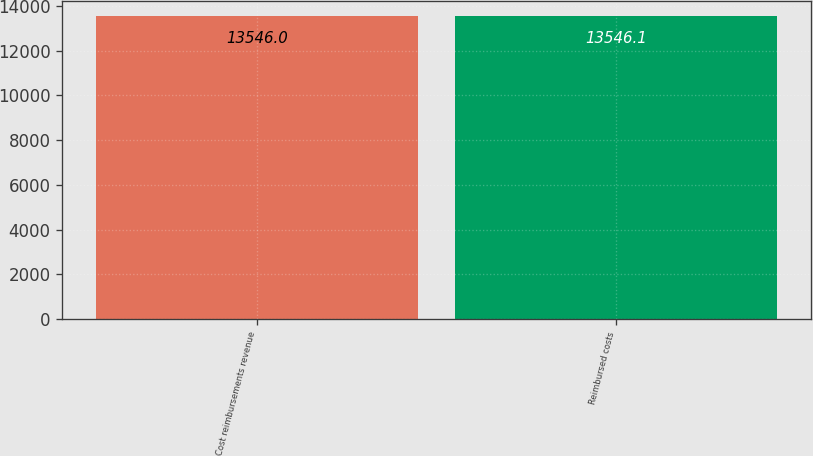Convert chart to OTSL. <chart><loc_0><loc_0><loc_500><loc_500><bar_chart><fcel>Cost reimbursements revenue<fcel>Reimbursed costs<nl><fcel>13546<fcel>13546.1<nl></chart> 